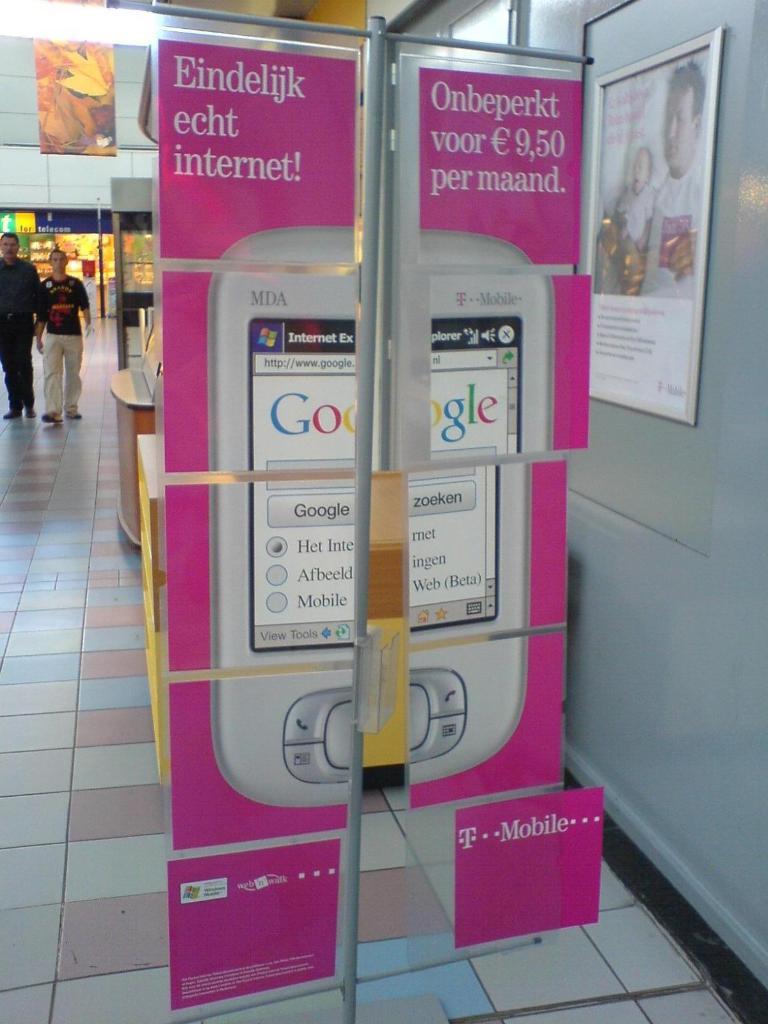What search engine is on the sign?
Make the answer very short. Google. 